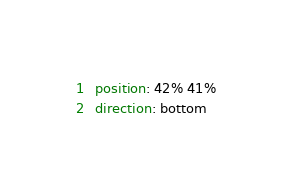Convert code to text. <code><loc_0><loc_0><loc_500><loc_500><_YAML_>  position: 42% 41%
  direction: bottom
</code> 